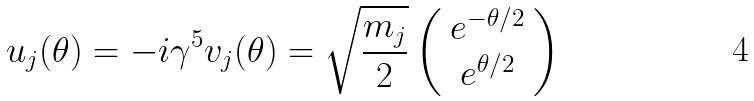Convert formula to latex. <formula><loc_0><loc_0><loc_500><loc_500>u _ { j } ( \theta ) = - i \gamma ^ { 5 } v _ { j } ( \theta ) = \sqrt { \frac { m _ { j } } { 2 } } \left ( \begin{array} { c } e ^ { - \theta / 2 } \\ e ^ { \theta / 2 } \end{array} \right ) \,</formula> 